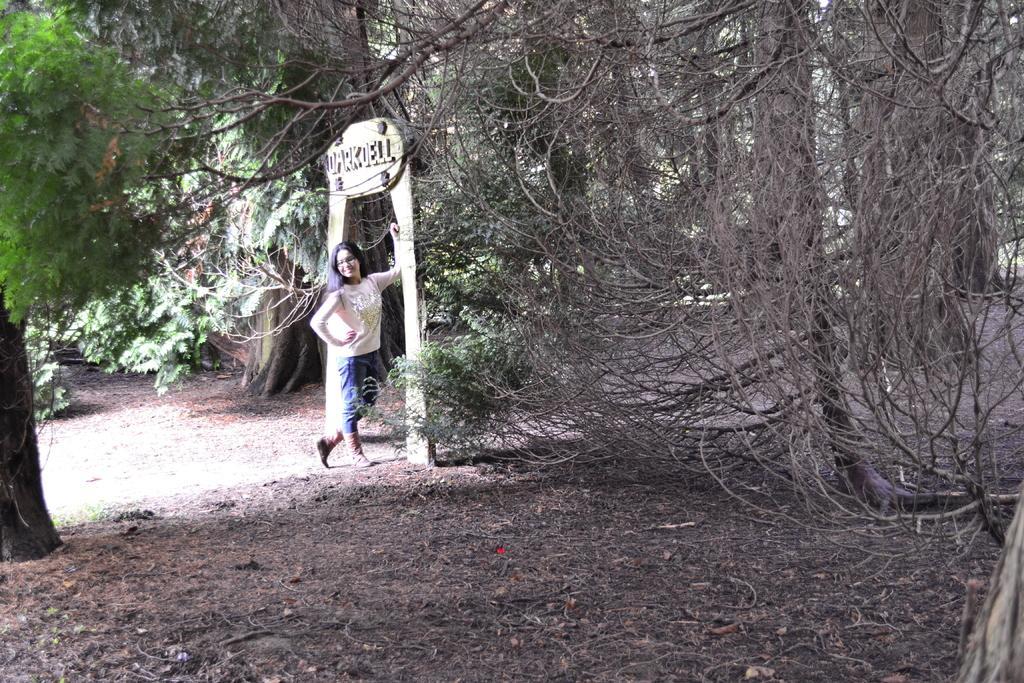Describe this image in one or two sentences. In this image we can see a woman wearing T-shirt and pant standing near the arch, we can some trees which are in green color and we can see some dry trees as well. 